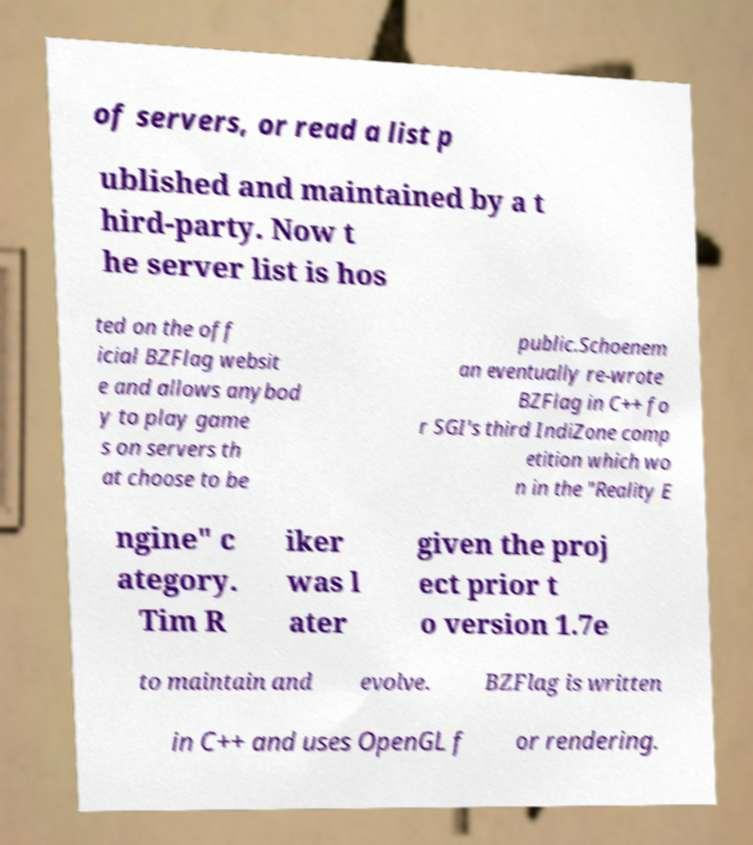Could you extract and type out the text from this image? of servers, or read a list p ublished and maintained by a t hird-party. Now t he server list is hos ted on the off icial BZFlag websit e and allows anybod y to play game s on servers th at choose to be public.Schoenem an eventually re-wrote BZFlag in C++ fo r SGI's third IndiZone comp etition which wo n in the "Reality E ngine" c ategory. Tim R iker was l ater given the proj ect prior t o version 1.7e to maintain and evolve. BZFlag is written in C++ and uses OpenGL f or rendering. 